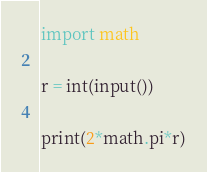<code> <loc_0><loc_0><loc_500><loc_500><_Python_>import math

r = int(input())

print(2*math.pi*r)</code> 